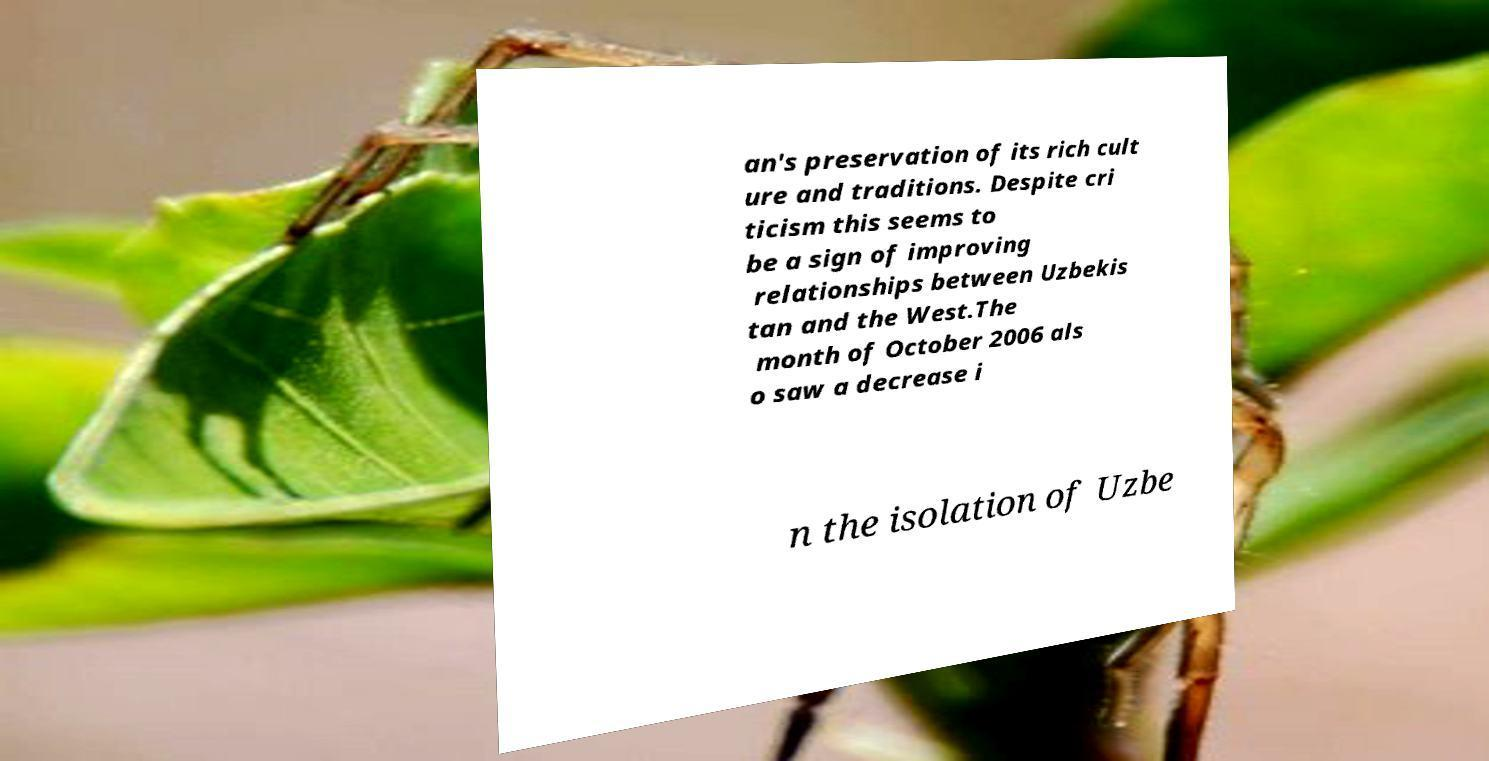Can you accurately transcribe the text from the provided image for me? an's preservation of its rich cult ure and traditions. Despite cri ticism this seems to be a sign of improving relationships between Uzbekis tan and the West.The month of October 2006 als o saw a decrease i n the isolation of Uzbe 